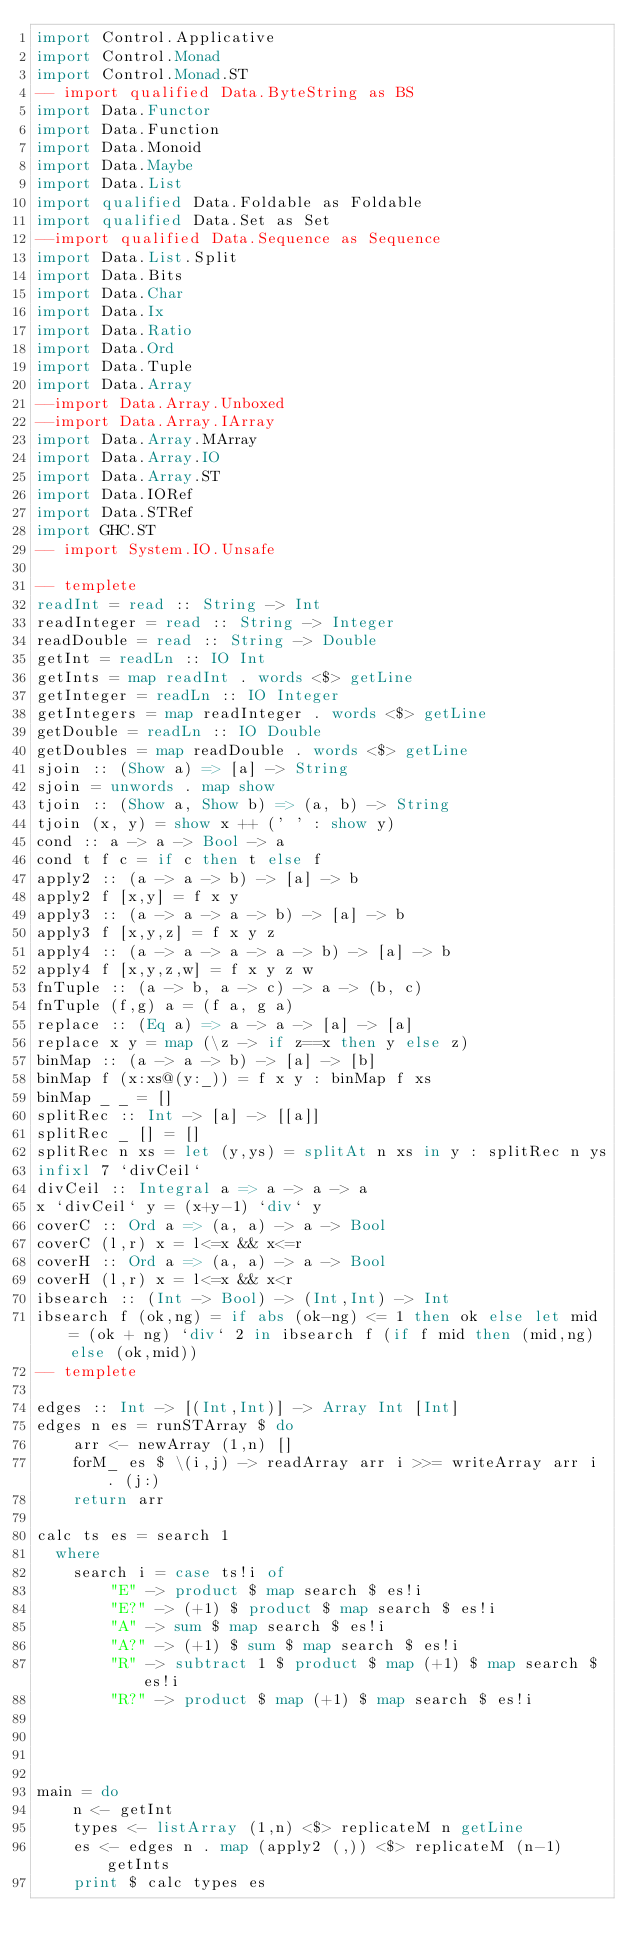Convert code to text. <code><loc_0><loc_0><loc_500><loc_500><_Haskell_>import Control.Applicative
import Control.Monad
import Control.Monad.ST
-- import qualified Data.ByteString as BS
import Data.Functor
import Data.Function
import Data.Monoid
import Data.Maybe
import Data.List
import qualified Data.Foldable as Foldable
import qualified Data.Set as Set
--import qualified Data.Sequence as Sequence
import Data.List.Split
import Data.Bits
import Data.Char
import Data.Ix
import Data.Ratio
import Data.Ord
import Data.Tuple
import Data.Array
--import Data.Array.Unboxed
--import Data.Array.IArray
import Data.Array.MArray
import Data.Array.IO
import Data.Array.ST
import Data.IORef
import Data.STRef
import GHC.ST
-- import System.IO.Unsafe
 
-- templete
readInt = read :: String -> Int
readInteger = read :: String -> Integer
readDouble = read :: String -> Double
getInt = readLn :: IO Int
getInts = map readInt . words <$> getLine
getInteger = readLn :: IO Integer
getIntegers = map readInteger . words <$> getLine
getDouble = readLn :: IO Double
getDoubles = map readDouble . words <$> getLine
sjoin :: (Show a) => [a] -> String
sjoin = unwords . map show
tjoin :: (Show a, Show b) => (a, b) -> String
tjoin (x, y) = show x ++ (' ' : show y)
cond :: a -> a -> Bool -> a
cond t f c = if c then t else f
apply2 :: (a -> a -> b) -> [a] -> b
apply2 f [x,y] = f x y
apply3 :: (a -> a -> a -> b) -> [a] -> b
apply3 f [x,y,z] = f x y z
apply4 :: (a -> a -> a -> a -> b) -> [a] -> b
apply4 f [x,y,z,w] = f x y z w
fnTuple :: (a -> b, a -> c) -> a -> (b, c)
fnTuple (f,g) a = (f a, g a)
replace :: (Eq a) => a -> a -> [a] -> [a]
replace x y = map (\z -> if z==x then y else z)
binMap :: (a -> a -> b) -> [a] -> [b]
binMap f (x:xs@(y:_)) = f x y : binMap f xs
binMap _ _ = []
splitRec :: Int -> [a] -> [[a]]
splitRec _ [] = []
splitRec n xs = let (y,ys) = splitAt n xs in y : splitRec n ys
infixl 7 `divCeil`
divCeil :: Integral a => a -> a -> a
x `divCeil` y = (x+y-1) `div` y
coverC :: Ord a => (a, a) -> a -> Bool
coverC (l,r) x = l<=x && x<=r
coverH :: Ord a => (a, a) -> a -> Bool
coverH (l,r) x = l<=x && x<r
ibsearch :: (Int -> Bool) -> (Int,Int) -> Int
ibsearch f (ok,ng) = if abs (ok-ng) <= 1 then ok else let mid = (ok + ng) `div` 2 in ibsearch f (if f mid then (mid,ng) else (ok,mid))
-- templete

edges :: Int -> [(Int,Int)] -> Array Int [Int]
edges n es = runSTArray $ do
    arr <- newArray (1,n) []
    forM_ es $ \(i,j) -> readArray arr i >>= writeArray arr i . (j:)
    return arr

calc ts es = search 1
  where
    search i = case ts!i of
        "E" -> product $ map search $ es!i
        "E?" -> (+1) $ product $ map search $ es!i
        "A" -> sum $ map search $ es!i
        "A?" -> (+1) $ sum $ map search $ es!i
        "R" -> subtract 1 $ product $ map (+1) $ map search $ es!i
        "R?" -> product $ map (+1) $ map search $ es!i
        
        


main = do
    n <- getInt
    types <- listArray (1,n) <$> replicateM n getLine
    es <- edges n . map (apply2 (,)) <$> replicateM (n-1) getInts
    print $ calc types es
    

</code> 